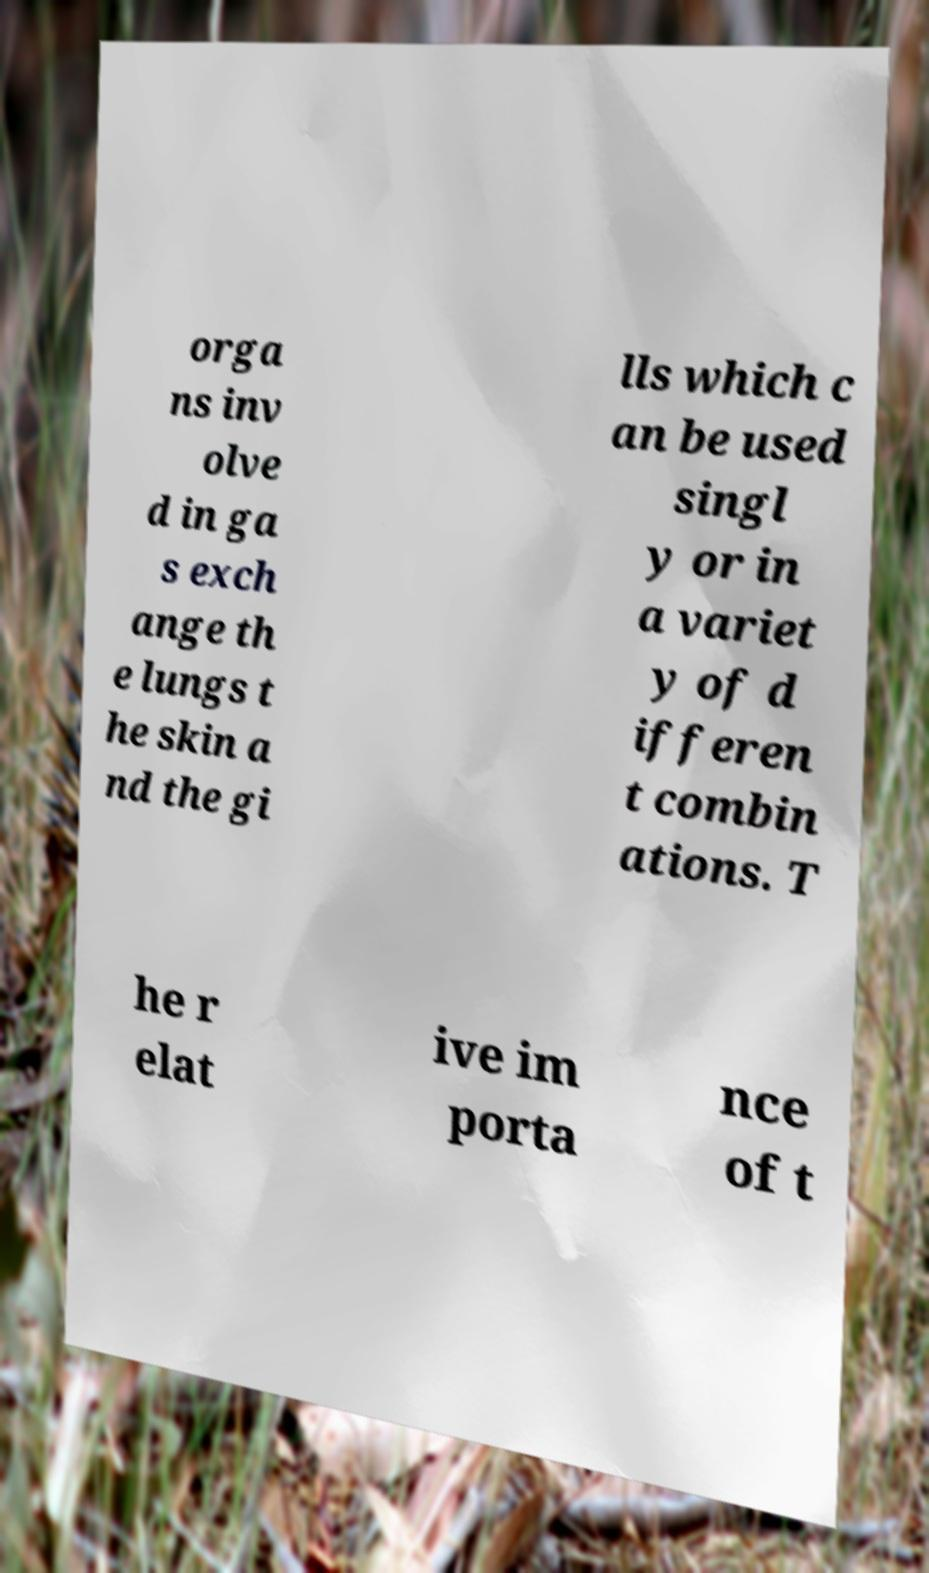There's text embedded in this image that I need extracted. Can you transcribe it verbatim? orga ns inv olve d in ga s exch ange th e lungs t he skin a nd the gi lls which c an be used singl y or in a variet y of d ifferen t combin ations. T he r elat ive im porta nce of t 